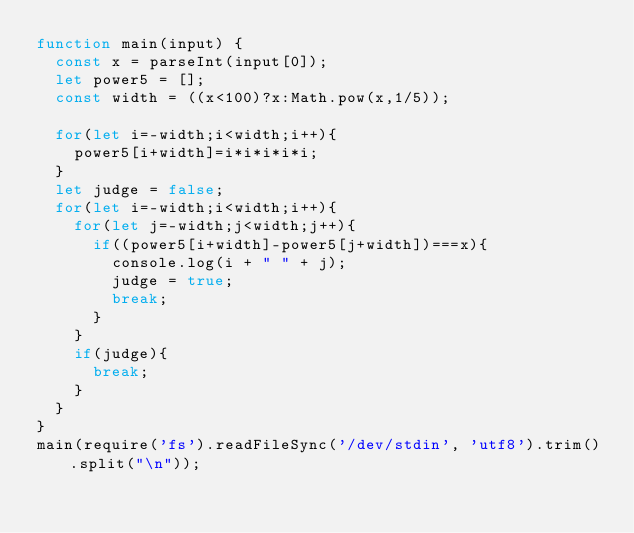Convert code to text. <code><loc_0><loc_0><loc_500><loc_500><_JavaScript_>function main(input) {
  const x = parseInt(input[0]);
  let power5 = [];
  const width = ((x<100)?x:Math.pow(x,1/5));

  for(let i=-width;i<width;i++){
    power5[i+width]=i*i*i*i*i;
  }
  let judge = false;
  for(let i=-width;i<width;i++){
    for(let j=-width;j<width;j++){
      if((power5[i+width]-power5[j+width])===x){
        console.log(i + " " + j);
        judge = true;
        break;
      }
    }
    if(judge){
      break;
    }
  }
}
main(require('fs').readFileSync('/dev/stdin', 'utf8').trim().split("\n"));</code> 